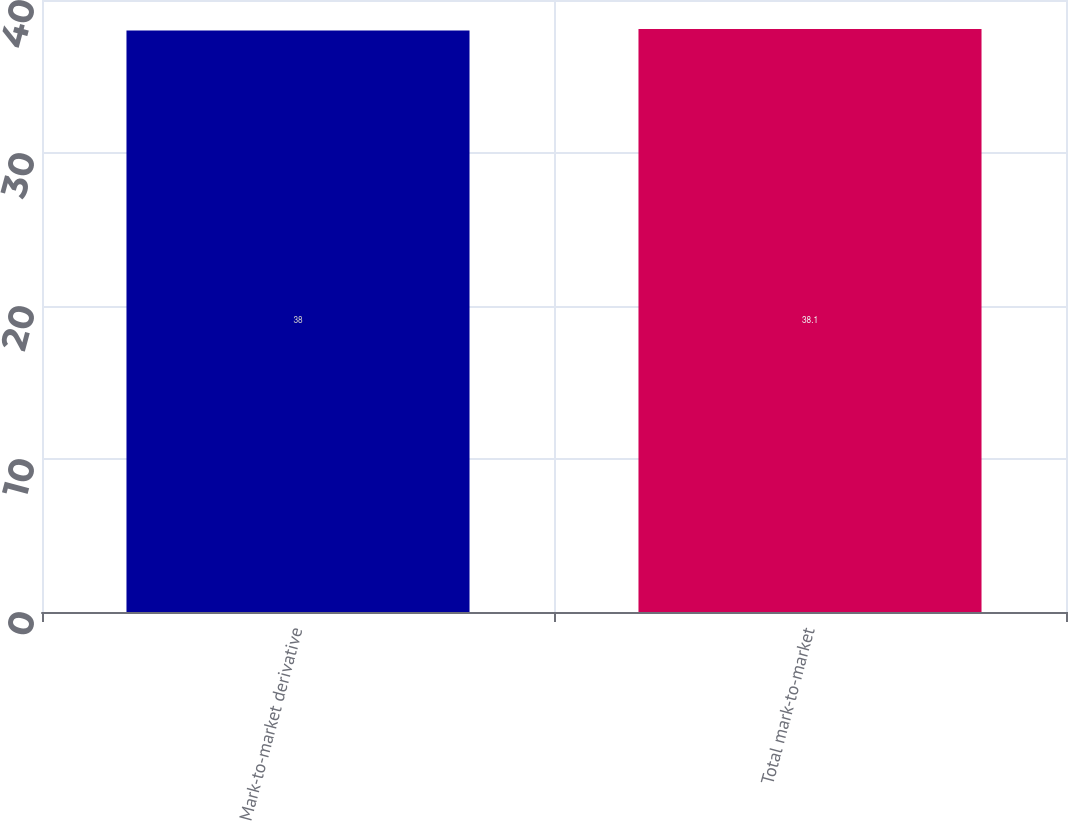Convert chart. <chart><loc_0><loc_0><loc_500><loc_500><bar_chart><fcel>Mark-to-market derivative<fcel>Total mark-to-market<nl><fcel>38<fcel>38.1<nl></chart> 